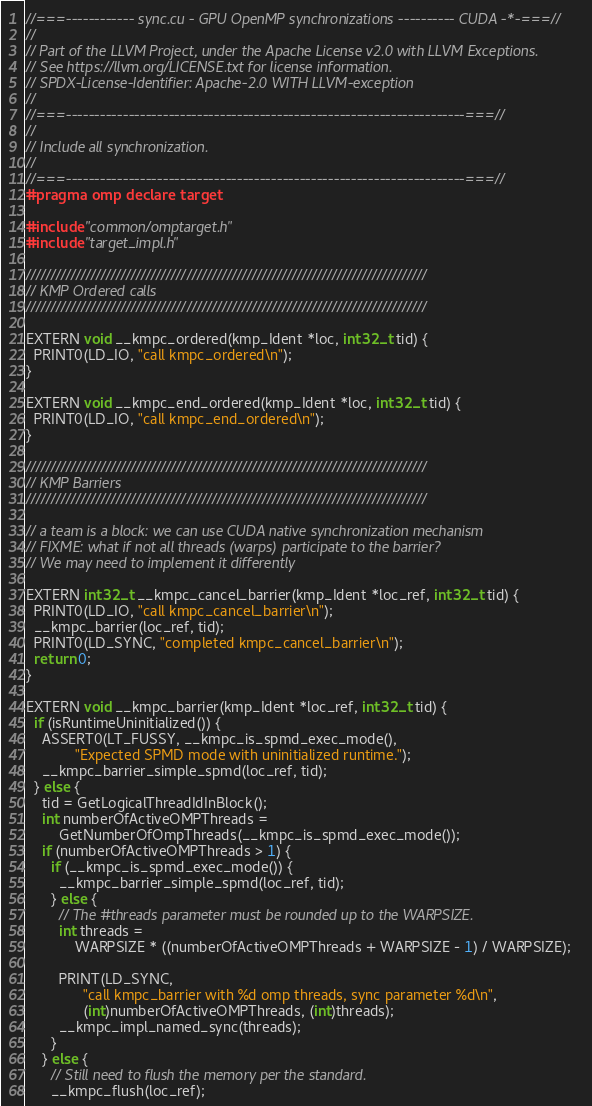Convert code to text. <code><loc_0><loc_0><loc_500><loc_500><_Cuda_>//===------------ sync.cu - GPU OpenMP synchronizations ---------- CUDA -*-===//
//
// Part of the LLVM Project, under the Apache License v2.0 with LLVM Exceptions.
// See https://llvm.org/LICENSE.txt for license information.
// SPDX-License-Identifier: Apache-2.0 WITH LLVM-exception
//
//===----------------------------------------------------------------------===//
//
// Include all synchronization.
//
//===----------------------------------------------------------------------===//
#pragma omp declare target

#include "common/omptarget.h"
#include "target_impl.h"

////////////////////////////////////////////////////////////////////////////////
// KMP Ordered calls
////////////////////////////////////////////////////////////////////////////////

EXTERN void __kmpc_ordered(kmp_Ident *loc, int32_t tid) {
  PRINT0(LD_IO, "call kmpc_ordered\n");
}

EXTERN void __kmpc_end_ordered(kmp_Ident *loc, int32_t tid) {
  PRINT0(LD_IO, "call kmpc_end_ordered\n");
}

////////////////////////////////////////////////////////////////////////////////
// KMP Barriers
////////////////////////////////////////////////////////////////////////////////

// a team is a block: we can use CUDA native synchronization mechanism
// FIXME: what if not all threads (warps) participate to the barrier?
// We may need to implement it differently

EXTERN int32_t __kmpc_cancel_barrier(kmp_Ident *loc_ref, int32_t tid) {
  PRINT0(LD_IO, "call kmpc_cancel_barrier\n");
  __kmpc_barrier(loc_ref, tid);
  PRINT0(LD_SYNC, "completed kmpc_cancel_barrier\n");
  return 0;
}

EXTERN void __kmpc_barrier(kmp_Ident *loc_ref, int32_t tid) {
  if (isRuntimeUninitialized()) {
    ASSERT0(LT_FUSSY, __kmpc_is_spmd_exec_mode(),
            "Expected SPMD mode with uninitialized runtime.");
    __kmpc_barrier_simple_spmd(loc_ref, tid);
  } else {
    tid = GetLogicalThreadIdInBlock();
    int numberOfActiveOMPThreads =
        GetNumberOfOmpThreads(__kmpc_is_spmd_exec_mode());
    if (numberOfActiveOMPThreads > 1) {
      if (__kmpc_is_spmd_exec_mode()) {
        __kmpc_barrier_simple_spmd(loc_ref, tid);
      } else {
        // The #threads parameter must be rounded up to the WARPSIZE.
        int threads =
            WARPSIZE * ((numberOfActiveOMPThreads + WARPSIZE - 1) / WARPSIZE);

        PRINT(LD_SYNC,
              "call kmpc_barrier with %d omp threads, sync parameter %d\n",
              (int)numberOfActiveOMPThreads, (int)threads);
        __kmpc_impl_named_sync(threads);
      }
    } else {
      // Still need to flush the memory per the standard.
      __kmpc_flush(loc_ref);</code> 